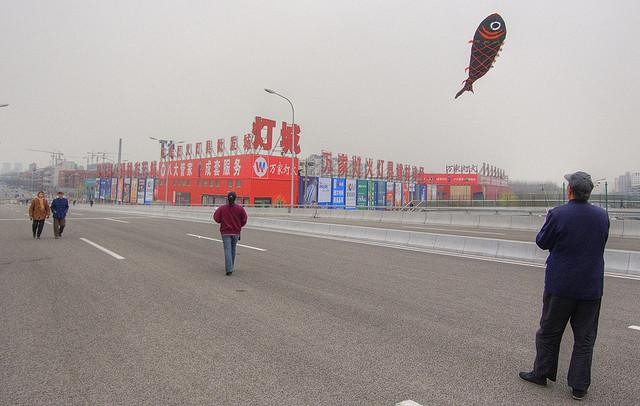What is the giant fish in the air?

Choices:
A) blimp
B) balloon
C) kite
D) sculpture kite 